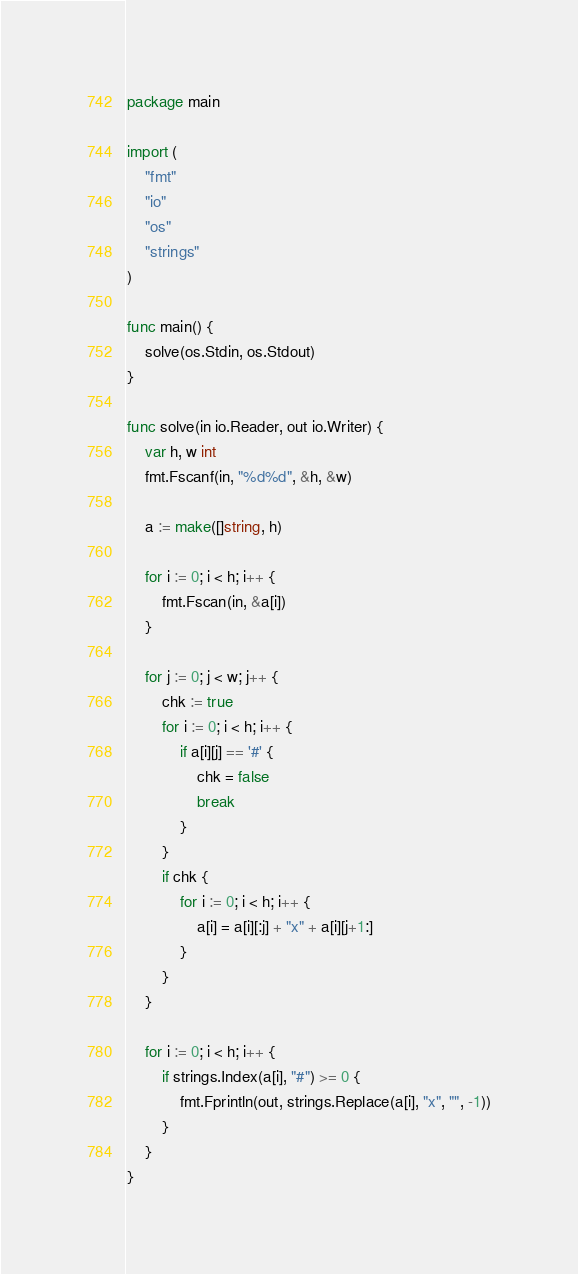Convert code to text. <code><loc_0><loc_0><loc_500><loc_500><_Go_>package main

import (
	"fmt"
	"io"
	"os"
	"strings"
)

func main() {
	solve(os.Stdin, os.Stdout)
}

func solve(in io.Reader, out io.Writer) {
	var h, w int
	fmt.Fscanf(in, "%d%d", &h, &w)

	a := make([]string, h)

	for i := 0; i < h; i++ {
		fmt.Fscan(in, &a[i])
	}

	for j := 0; j < w; j++ {
		chk := true
		for i := 0; i < h; i++ {
			if a[i][j] == '#' {
				chk = false
				break
			}
		}
		if chk {
			for i := 0; i < h; i++ {
				a[i] = a[i][:j] + "x" + a[i][j+1:]
			}
		}
	}

	for i := 0; i < h; i++ {
		if strings.Index(a[i], "#") >= 0 {
			fmt.Fprintln(out, strings.Replace(a[i], "x", "", -1))
		}
	}
}
</code> 